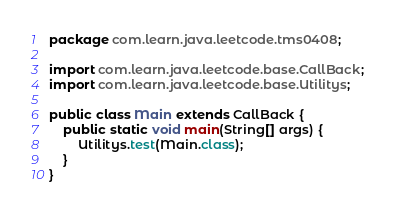<code> <loc_0><loc_0><loc_500><loc_500><_Java_>package com.learn.java.leetcode.tms0408;

import com.learn.java.leetcode.base.CallBack;
import com.learn.java.leetcode.base.Utilitys;

public class Main extends CallBack {
	public static void main(String[] args) {
		Utilitys.test(Main.class);
	}
}
</code> 